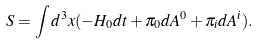Convert formula to latex. <formula><loc_0><loc_0><loc_500><loc_500>S = \int d ^ { 3 } x ( - H _ { 0 } d t + \pi _ { 0 } d A ^ { 0 } + \pi _ { i } d A ^ { i } ) .</formula> 